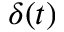<formula> <loc_0><loc_0><loc_500><loc_500>\delta ( t )</formula> 